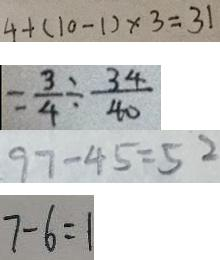<formula> <loc_0><loc_0><loc_500><loc_500>4 + ( 1 0 - 1 ) \times 3 = 3 1 
 = \frac { 3 } { 4 } + \frac { 3 4 } { 4 0 } 
 9 7 - 4 5 = 5 2 
 7 - 6 = 1</formula> 